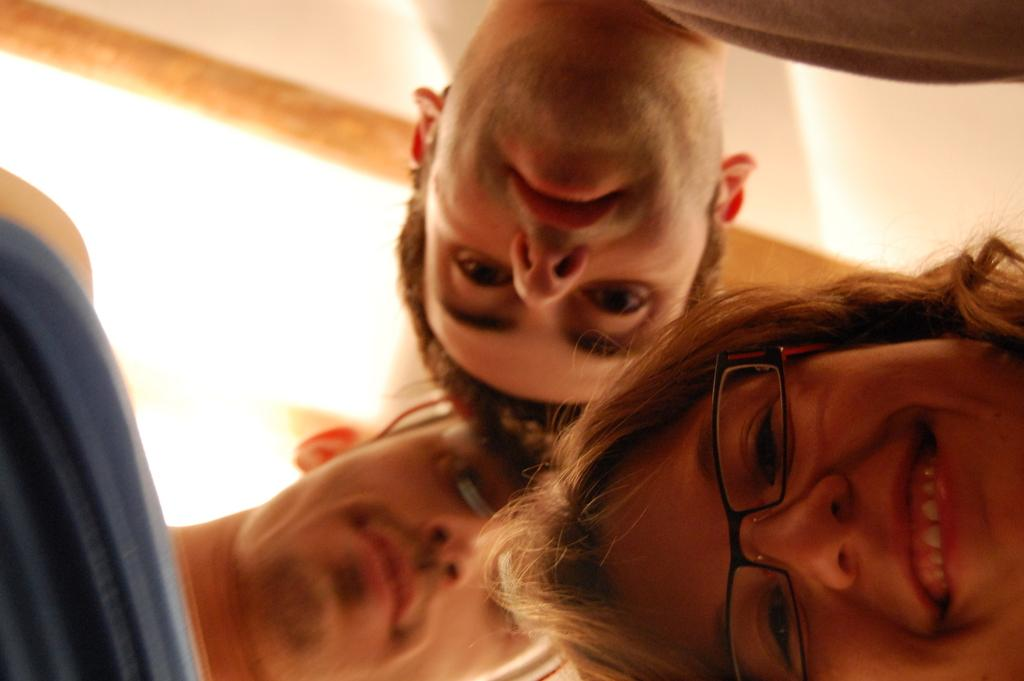What is the perspective of the image? The image shows a bottom view of three persons. Can you describe the position of one of the persons in the image? There is a person in the bottom right of the image. What can be observed about the person in the bottom right? The person in the bottom right is wearing spectacles. What type of cloth is being used to make a decision in the image? There is no cloth or decision-making process depicted in the image; it shows a bottom view of three persons, one of whom is wearing spectacles. 